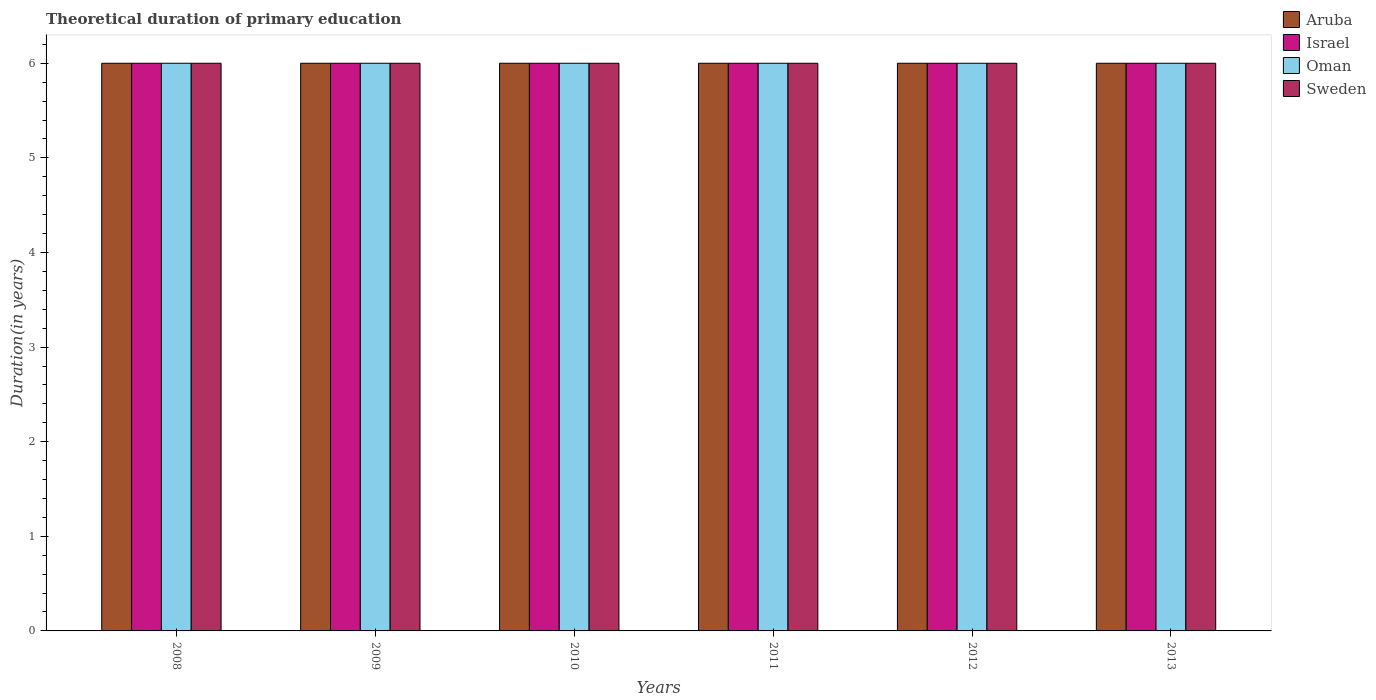How many different coloured bars are there?
Offer a terse response. 4. How many groups of bars are there?
Ensure brevity in your answer.  6. How many bars are there on the 5th tick from the left?
Offer a very short reply. 4. How many bars are there on the 3rd tick from the right?
Offer a terse response. 4. What is the label of the 6th group of bars from the left?
Provide a short and direct response. 2013. In how many cases, is the number of bars for a given year not equal to the number of legend labels?
Provide a succinct answer. 0. What is the total theoretical duration of primary education in Sweden in 2013?
Provide a succinct answer. 6. Across all years, what is the maximum total theoretical duration of primary education in Sweden?
Offer a very short reply. 6. In which year was the total theoretical duration of primary education in Israel maximum?
Your answer should be compact. 2008. What is the difference between the total theoretical duration of primary education in Israel in 2008 and that in 2010?
Provide a succinct answer. 0. What is the difference between the total theoretical duration of primary education in Israel in 2010 and the total theoretical duration of primary education in Oman in 2009?
Your response must be concise. 0. In how many years, is the total theoretical duration of primary education in Sweden greater than 1.4 years?
Keep it short and to the point. 6. What is the ratio of the total theoretical duration of primary education in Sweden in 2012 to that in 2013?
Your response must be concise. 1. What is the difference between the highest and the second highest total theoretical duration of primary education in Oman?
Your answer should be compact. 0. Is it the case that in every year, the sum of the total theoretical duration of primary education in Israel and total theoretical duration of primary education in Sweden is greater than the sum of total theoretical duration of primary education in Aruba and total theoretical duration of primary education in Oman?
Keep it short and to the point. No. What does the 4th bar from the right in 2011 represents?
Your answer should be very brief. Aruba. Is it the case that in every year, the sum of the total theoretical duration of primary education in Sweden and total theoretical duration of primary education in Aruba is greater than the total theoretical duration of primary education in Israel?
Provide a short and direct response. Yes. Are all the bars in the graph horizontal?
Offer a very short reply. No. Does the graph contain any zero values?
Provide a succinct answer. No. Where does the legend appear in the graph?
Provide a succinct answer. Top right. What is the title of the graph?
Your response must be concise. Theoretical duration of primary education. Does "Sri Lanka" appear as one of the legend labels in the graph?
Keep it short and to the point. No. What is the label or title of the X-axis?
Your response must be concise. Years. What is the label or title of the Y-axis?
Provide a short and direct response. Duration(in years). What is the Duration(in years) in Aruba in 2008?
Your answer should be compact. 6. What is the Duration(in years) of Oman in 2009?
Provide a succinct answer. 6. What is the Duration(in years) in Sweden in 2009?
Your answer should be compact. 6. What is the Duration(in years) of Aruba in 2010?
Make the answer very short. 6. What is the Duration(in years) of Sweden in 2010?
Keep it short and to the point. 6. What is the Duration(in years) in Aruba in 2011?
Keep it short and to the point. 6. What is the Duration(in years) of Israel in 2011?
Give a very brief answer. 6. What is the Duration(in years) of Sweden in 2011?
Your response must be concise. 6. What is the Duration(in years) of Aruba in 2012?
Ensure brevity in your answer.  6. What is the Duration(in years) of Israel in 2012?
Provide a short and direct response. 6. What is the Duration(in years) in Oman in 2012?
Your response must be concise. 6. What is the Duration(in years) of Aruba in 2013?
Your answer should be very brief. 6. Across all years, what is the maximum Duration(in years) in Aruba?
Your answer should be compact. 6. Across all years, what is the maximum Duration(in years) of Israel?
Offer a terse response. 6. Across all years, what is the minimum Duration(in years) of Oman?
Ensure brevity in your answer.  6. What is the total Duration(in years) of Israel in the graph?
Provide a short and direct response. 36. What is the total Duration(in years) in Oman in the graph?
Offer a terse response. 36. What is the total Duration(in years) of Sweden in the graph?
Offer a terse response. 36. What is the difference between the Duration(in years) in Aruba in 2008 and that in 2010?
Provide a short and direct response. 0. What is the difference between the Duration(in years) in Israel in 2008 and that in 2010?
Provide a short and direct response. 0. What is the difference between the Duration(in years) in Oman in 2008 and that in 2010?
Offer a terse response. 0. What is the difference between the Duration(in years) of Sweden in 2008 and that in 2010?
Your answer should be very brief. 0. What is the difference between the Duration(in years) of Sweden in 2008 and that in 2011?
Give a very brief answer. 0. What is the difference between the Duration(in years) in Aruba in 2008 and that in 2012?
Make the answer very short. 0. What is the difference between the Duration(in years) of Aruba in 2009 and that in 2010?
Your answer should be very brief. 0. What is the difference between the Duration(in years) in Sweden in 2009 and that in 2010?
Ensure brevity in your answer.  0. What is the difference between the Duration(in years) in Israel in 2009 and that in 2011?
Keep it short and to the point. 0. What is the difference between the Duration(in years) of Sweden in 2009 and that in 2011?
Your answer should be very brief. 0. What is the difference between the Duration(in years) in Aruba in 2009 and that in 2012?
Your answer should be very brief. 0. What is the difference between the Duration(in years) of Oman in 2009 and that in 2012?
Provide a succinct answer. 0. What is the difference between the Duration(in years) of Oman in 2009 and that in 2013?
Keep it short and to the point. 0. What is the difference between the Duration(in years) of Sweden in 2009 and that in 2013?
Your response must be concise. 0. What is the difference between the Duration(in years) of Aruba in 2010 and that in 2011?
Make the answer very short. 0. What is the difference between the Duration(in years) in Israel in 2010 and that in 2011?
Give a very brief answer. 0. What is the difference between the Duration(in years) of Sweden in 2010 and that in 2011?
Provide a short and direct response. 0. What is the difference between the Duration(in years) of Israel in 2010 and that in 2012?
Your response must be concise. 0. What is the difference between the Duration(in years) of Sweden in 2010 and that in 2012?
Keep it short and to the point. 0. What is the difference between the Duration(in years) of Oman in 2010 and that in 2013?
Your response must be concise. 0. What is the difference between the Duration(in years) in Aruba in 2011 and that in 2012?
Your response must be concise. 0. What is the difference between the Duration(in years) in Israel in 2011 and that in 2012?
Provide a succinct answer. 0. What is the difference between the Duration(in years) of Oman in 2011 and that in 2012?
Your response must be concise. 0. What is the difference between the Duration(in years) in Aruba in 2011 and that in 2013?
Your response must be concise. 0. What is the difference between the Duration(in years) of Sweden in 2011 and that in 2013?
Provide a short and direct response. 0. What is the difference between the Duration(in years) in Aruba in 2012 and that in 2013?
Give a very brief answer. 0. What is the difference between the Duration(in years) of Oman in 2012 and that in 2013?
Your response must be concise. 0. What is the difference between the Duration(in years) of Sweden in 2012 and that in 2013?
Offer a terse response. 0. What is the difference between the Duration(in years) in Aruba in 2008 and the Duration(in years) in Oman in 2009?
Keep it short and to the point. 0. What is the difference between the Duration(in years) in Israel in 2008 and the Duration(in years) in Oman in 2009?
Give a very brief answer. 0. What is the difference between the Duration(in years) in Israel in 2008 and the Duration(in years) in Sweden in 2009?
Your answer should be very brief. 0. What is the difference between the Duration(in years) in Aruba in 2008 and the Duration(in years) in Israel in 2010?
Give a very brief answer. 0. What is the difference between the Duration(in years) of Aruba in 2008 and the Duration(in years) of Oman in 2010?
Ensure brevity in your answer.  0. What is the difference between the Duration(in years) in Israel in 2008 and the Duration(in years) in Oman in 2010?
Ensure brevity in your answer.  0. What is the difference between the Duration(in years) of Israel in 2008 and the Duration(in years) of Sweden in 2010?
Make the answer very short. 0. What is the difference between the Duration(in years) of Oman in 2008 and the Duration(in years) of Sweden in 2010?
Make the answer very short. 0. What is the difference between the Duration(in years) in Aruba in 2008 and the Duration(in years) in Oman in 2011?
Keep it short and to the point. 0. What is the difference between the Duration(in years) of Aruba in 2008 and the Duration(in years) of Sweden in 2011?
Offer a terse response. 0. What is the difference between the Duration(in years) in Israel in 2008 and the Duration(in years) in Oman in 2011?
Provide a short and direct response. 0. What is the difference between the Duration(in years) in Oman in 2008 and the Duration(in years) in Sweden in 2011?
Your answer should be compact. 0. What is the difference between the Duration(in years) in Aruba in 2008 and the Duration(in years) in Oman in 2012?
Your answer should be compact. 0. What is the difference between the Duration(in years) in Israel in 2008 and the Duration(in years) in Sweden in 2012?
Your response must be concise. 0. What is the difference between the Duration(in years) of Oman in 2008 and the Duration(in years) of Sweden in 2012?
Ensure brevity in your answer.  0. What is the difference between the Duration(in years) of Aruba in 2008 and the Duration(in years) of Oman in 2013?
Offer a very short reply. 0. What is the difference between the Duration(in years) in Aruba in 2008 and the Duration(in years) in Sweden in 2013?
Provide a short and direct response. 0. What is the difference between the Duration(in years) in Israel in 2008 and the Duration(in years) in Oman in 2013?
Your answer should be very brief. 0. What is the difference between the Duration(in years) of Aruba in 2009 and the Duration(in years) of Israel in 2010?
Ensure brevity in your answer.  0. What is the difference between the Duration(in years) in Israel in 2009 and the Duration(in years) in Oman in 2010?
Offer a very short reply. 0. What is the difference between the Duration(in years) in Israel in 2009 and the Duration(in years) in Sweden in 2010?
Give a very brief answer. 0. What is the difference between the Duration(in years) of Oman in 2009 and the Duration(in years) of Sweden in 2010?
Offer a terse response. 0. What is the difference between the Duration(in years) of Aruba in 2009 and the Duration(in years) of Israel in 2011?
Keep it short and to the point. 0. What is the difference between the Duration(in years) of Israel in 2009 and the Duration(in years) of Sweden in 2011?
Keep it short and to the point. 0. What is the difference between the Duration(in years) of Aruba in 2009 and the Duration(in years) of Sweden in 2012?
Your answer should be very brief. 0. What is the difference between the Duration(in years) in Israel in 2009 and the Duration(in years) in Sweden in 2012?
Provide a succinct answer. 0. What is the difference between the Duration(in years) of Oman in 2009 and the Duration(in years) of Sweden in 2012?
Your answer should be compact. 0. What is the difference between the Duration(in years) in Aruba in 2009 and the Duration(in years) in Sweden in 2013?
Your answer should be compact. 0. What is the difference between the Duration(in years) of Aruba in 2010 and the Duration(in years) of Israel in 2012?
Provide a succinct answer. 0. What is the difference between the Duration(in years) in Aruba in 2010 and the Duration(in years) in Oman in 2012?
Provide a succinct answer. 0. What is the difference between the Duration(in years) in Israel in 2010 and the Duration(in years) in Oman in 2013?
Your answer should be very brief. 0. What is the difference between the Duration(in years) in Israel in 2010 and the Duration(in years) in Sweden in 2013?
Your answer should be very brief. 0. What is the difference between the Duration(in years) of Aruba in 2011 and the Duration(in years) of Israel in 2012?
Your response must be concise. 0. What is the difference between the Duration(in years) in Aruba in 2011 and the Duration(in years) in Oman in 2012?
Offer a very short reply. 0. What is the difference between the Duration(in years) of Aruba in 2011 and the Duration(in years) of Sweden in 2012?
Your answer should be very brief. 0. What is the difference between the Duration(in years) in Israel in 2011 and the Duration(in years) in Sweden in 2012?
Offer a terse response. 0. What is the difference between the Duration(in years) in Aruba in 2011 and the Duration(in years) in Israel in 2013?
Your response must be concise. 0. What is the difference between the Duration(in years) in Aruba in 2011 and the Duration(in years) in Oman in 2013?
Ensure brevity in your answer.  0. What is the difference between the Duration(in years) of Oman in 2011 and the Duration(in years) of Sweden in 2013?
Make the answer very short. 0. What is the difference between the Duration(in years) in Aruba in 2012 and the Duration(in years) in Oman in 2013?
Your answer should be very brief. 0. What is the difference between the Duration(in years) in Oman in 2012 and the Duration(in years) in Sweden in 2013?
Offer a terse response. 0. What is the average Duration(in years) in Aruba per year?
Your answer should be compact. 6. What is the average Duration(in years) in Oman per year?
Make the answer very short. 6. What is the average Duration(in years) in Sweden per year?
Keep it short and to the point. 6. In the year 2008, what is the difference between the Duration(in years) of Aruba and Duration(in years) of Sweden?
Your response must be concise. 0. In the year 2008, what is the difference between the Duration(in years) in Israel and Duration(in years) in Oman?
Ensure brevity in your answer.  0. In the year 2008, what is the difference between the Duration(in years) of Israel and Duration(in years) of Sweden?
Keep it short and to the point. 0. In the year 2009, what is the difference between the Duration(in years) of Israel and Duration(in years) of Oman?
Provide a short and direct response. 0. In the year 2009, what is the difference between the Duration(in years) in Oman and Duration(in years) in Sweden?
Your response must be concise. 0. In the year 2010, what is the difference between the Duration(in years) in Aruba and Duration(in years) in Oman?
Ensure brevity in your answer.  0. In the year 2011, what is the difference between the Duration(in years) in Aruba and Duration(in years) in Oman?
Your answer should be very brief. 0. In the year 2011, what is the difference between the Duration(in years) in Aruba and Duration(in years) in Sweden?
Your answer should be compact. 0. In the year 2011, what is the difference between the Duration(in years) of Israel and Duration(in years) of Oman?
Offer a terse response. 0. In the year 2012, what is the difference between the Duration(in years) of Aruba and Duration(in years) of Oman?
Your response must be concise. 0. In the year 2012, what is the difference between the Duration(in years) of Aruba and Duration(in years) of Sweden?
Offer a very short reply. 0. In the year 2012, what is the difference between the Duration(in years) of Israel and Duration(in years) of Oman?
Your answer should be compact. 0. In the year 2012, what is the difference between the Duration(in years) of Israel and Duration(in years) of Sweden?
Your answer should be very brief. 0. In the year 2013, what is the difference between the Duration(in years) of Aruba and Duration(in years) of Israel?
Offer a terse response. 0. In the year 2013, what is the difference between the Duration(in years) of Aruba and Duration(in years) of Oman?
Your answer should be compact. 0. In the year 2013, what is the difference between the Duration(in years) of Israel and Duration(in years) of Sweden?
Keep it short and to the point. 0. In the year 2013, what is the difference between the Duration(in years) of Oman and Duration(in years) of Sweden?
Your answer should be very brief. 0. What is the ratio of the Duration(in years) in Aruba in 2008 to that in 2009?
Your answer should be very brief. 1. What is the ratio of the Duration(in years) in Oman in 2008 to that in 2009?
Offer a terse response. 1. What is the ratio of the Duration(in years) in Sweden in 2008 to that in 2009?
Ensure brevity in your answer.  1. What is the ratio of the Duration(in years) in Oman in 2008 to that in 2010?
Your response must be concise. 1. What is the ratio of the Duration(in years) in Sweden in 2008 to that in 2010?
Offer a terse response. 1. What is the ratio of the Duration(in years) of Israel in 2008 to that in 2011?
Keep it short and to the point. 1. What is the ratio of the Duration(in years) in Aruba in 2008 to that in 2012?
Offer a very short reply. 1. What is the ratio of the Duration(in years) of Israel in 2008 to that in 2012?
Keep it short and to the point. 1. What is the ratio of the Duration(in years) in Oman in 2008 to that in 2012?
Make the answer very short. 1. What is the ratio of the Duration(in years) of Sweden in 2008 to that in 2012?
Offer a very short reply. 1. What is the ratio of the Duration(in years) in Oman in 2008 to that in 2013?
Your answer should be compact. 1. What is the ratio of the Duration(in years) of Aruba in 2009 to that in 2010?
Your response must be concise. 1. What is the ratio of the Duration(in years) of Oman in 2009 to that in 2010?
Make the answer very short. 1. What is the ratio of the Duration(in years) in Sweden in 2009 to that in 2010?
Keep it short and to the point. 1. What is the ratio of the Duration(in years) of Aruba in 2009 to that in 2012?
Your answer should be very brief. 1. What is the ratio of the Duration(in years) in Aruba in 2009 to that in 2013?
Your answer should be very brief. 1. What is the ratio of the Duration(in years) in Oman in 2009 to that in 2013?
Ensure brevity in your answer.  1. What is the ratio of the Duration(in years) of Aruba in 2010 to that in 2011?
Provide a short and direct response. 1. What is the ratio of the Duration(in years) of Oman in 2010 to that in 2011?
Keep it short and to the point. 1. What is the ratio of the Duration(in years) of Sweden in 2010 to that in 2011?
Make the answer very short. 1. What is the ratio of the Duration(in years) of Aruba in 2010 to that in 2012?
Make the answer very short. 1. What is the ratio of the Duration(in years) of Israel in 2010 to that in 2012?
Provide a short and direct response. 1. What is the ratio of the Duration(in years) in Aruba in 2010 to that in 2013?
Provide a short and direct response. 1. What is the ratio of the Duration(in years) in Israel in 2010 to that in 2013?
Your answer should be compact. 1. What is the ratio of the Duration(in years) in Oman in 2010 to that in 2013?
Your response must be concise. 1. What is the ratio of the Duration(in years) in Israel in 2011 to that in 2012?
Provide a succinct answer. 1. What is the ratio of the Duration(in years) of Israel in 2011 to that in 2013?
Keep it short and to the point. 1. What is the ratio of the Duration(in years) of Aruba in 2012 to that in 2013?
Provide a succinct answer. 1. What is the ratio of the Duration(in years) of Oman in 2012 to that in 2013?
Provide a short and direct response. 1. What is the difference between the highest and the second highest Duration(in years) of Aruba?
Keep it short and to the point. 0. What is the difference between the highest and the second highest Duration(in years) in Israel?
Ensure brevity in your answer.  0. What is the difference between the highest and the lowest Duration(in years) in Aruba?
Provide a succinct answer. 0. What is the difference between the highest and the lowest Duration(in years) of Oman?
Offer a terse response. 0. What is the difference between the highest and the lowest Duration(in years) in Sweden?
Ensure brevity in your answer.  0. 